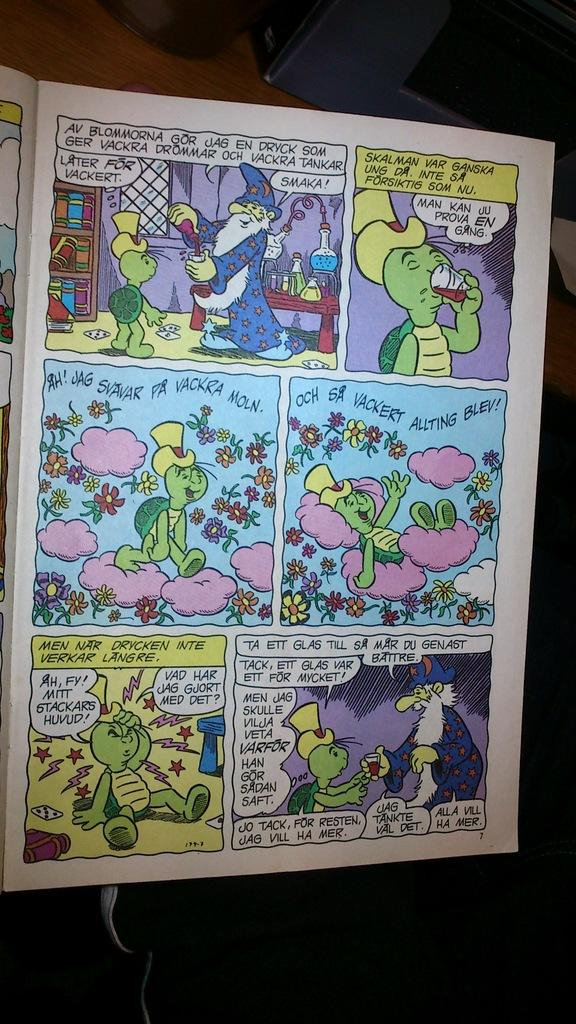Provide a one-sentence caption for the provided image. A cartoon book that is opened to page 7. 